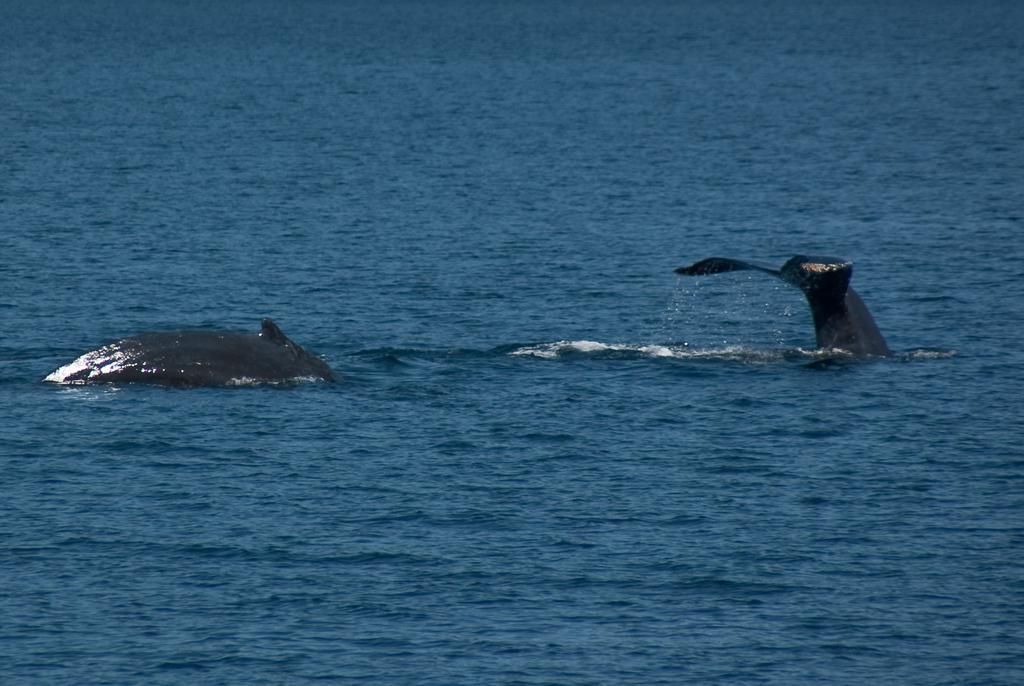What animals are present in the image? There are two dolphins in the image. Where are the dolphins located? The dolphins are in the water. What type of water can be seen in the image? The water appears to be part of an ocean. What type of oatmeal is being served to the dolphins in the image? There is no oatmeal present in the image; it features two dolphins in the water. 